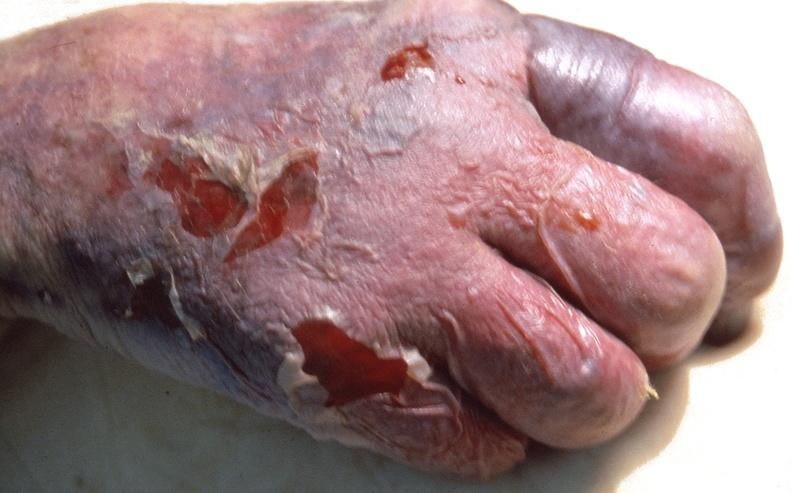where is this?
Answer the question using a single word or phrase. Skin 